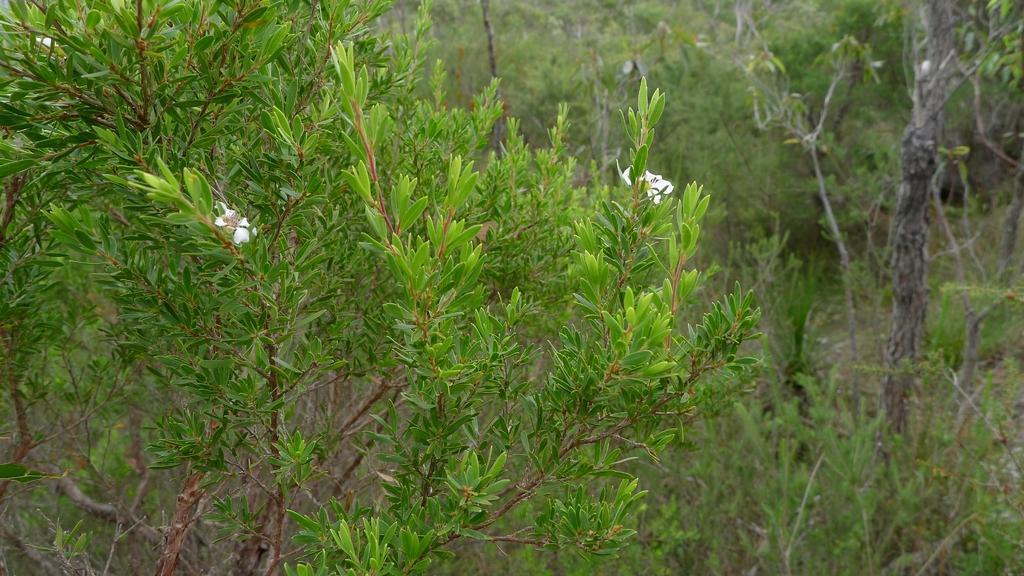Describe this image in one or two sentences. In this image I can see many plants and trees. And there are the white color flowers to the plant. 